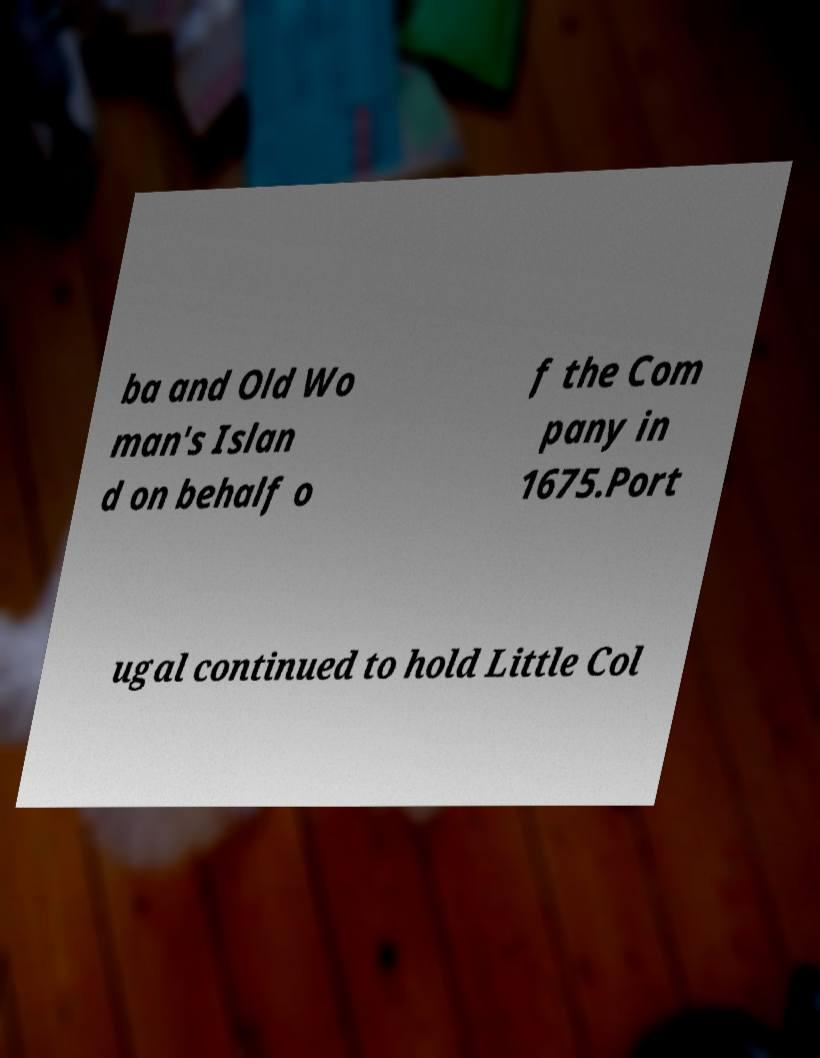There's text embedded in this image that I need extracted. Can you transcribe it verbatim? ba and Old Wo man's Islan d on behalf o f the Com pany in 1675.Port ugal continued to hold Little Col 